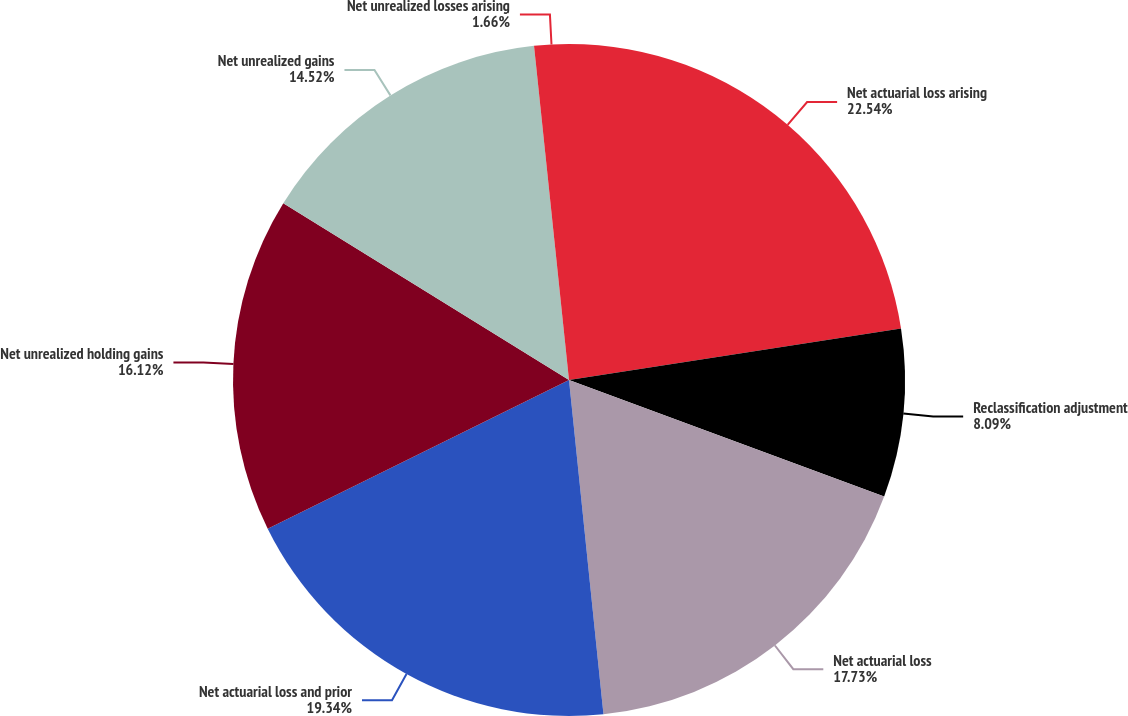Convert chart to OTSL. <chart><loc_0><loc_0><loc_500><loc_500><pie_chart><fcel>Net actuarial loss arising<fcel>Reclassification adjustment<fcel>Net actuarial loss<fcel>Net actuarial loss and prior<fcel>Net unrealized holding gains<fcel>Net unrealized gains<fcel>Net unrealized losses arising<nl><fcel>22.55%<fcel>8.09%<fcel>17.73%<fcel>19.34%<fcel>16.12%<fcel>14.52%<fcel>1.66%<nl></chart> 